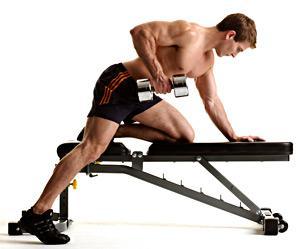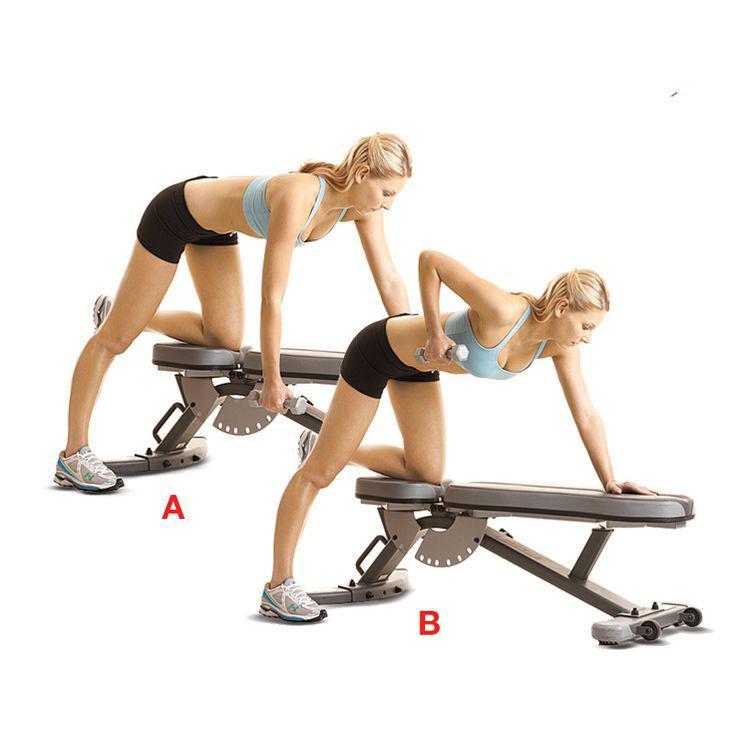The first image is the image on the left, the second image is the image on the right. Given the left and right images, does the statement "There is only one man in at least one image." hold true? Answer yes or no. Yes. 